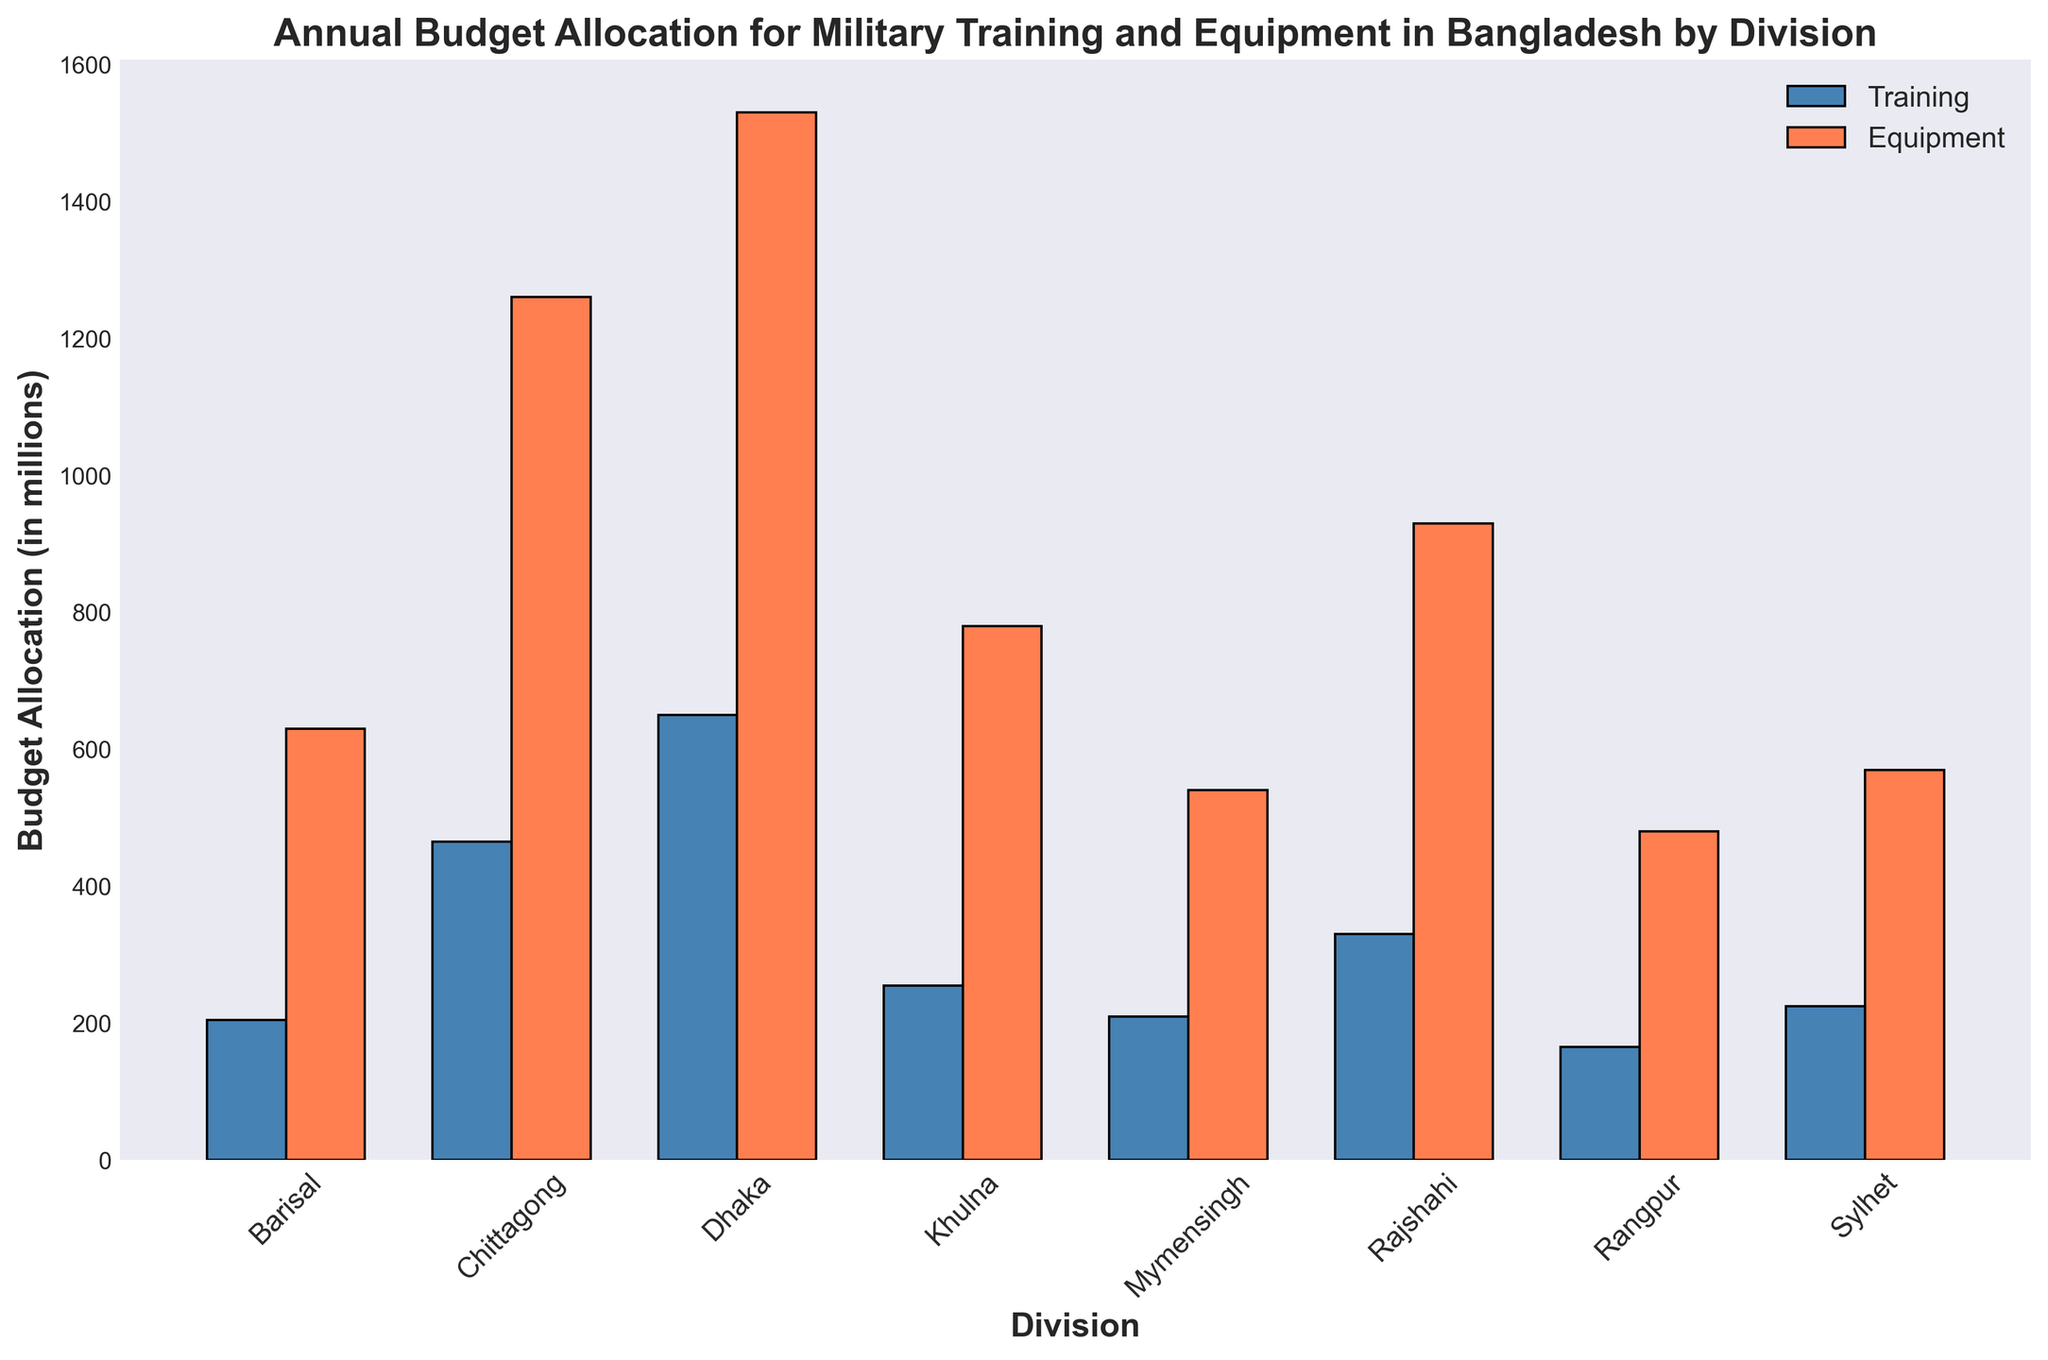Which division has the highest budget allocation for military training? The tallest blue bar represents the division with the highest allocation for military training. In the plot, Dhaka's blue bar is the highest.
Answer: Dhaka Which division has the lowest budget allocation for equipment? The shortest coral (red) bar represents the division with the lowest allocation for equipment. In the plot, Rangpur's coral bar is the shortest.
Answer: Rangpur What is the total budget allocation (Training + Equipment) for the Sylhet division? Add the height of Sylhet's blue bar (Training) and coral bar (Equipment). The Training budget is 225, and the Equipment budget is 570. Therefore, the total allocation is 225 + 570.
Answer: 395 Compare the budget allocation between Dhaka and Chittagong for equipment, and identify which division has a higher allocation. Compare the height of Dhaka's coral bar with Chittagong's coral bar. Dhaka's bar is higher in comparison to Chittagong's.
Answer: Dhaka What is the difference in budget allocation for training between Khulna and Barisal? Subtract the height of Barisal's blue bar (90) from Khulna's blue bar (255). Therefore, the difference is 255 - 90.
Answer: 165 Which division has a higher combined budget allocation for military training and equipment - Rajshahi or Mymensingh? Calculate the sum of the Training and Equipment budgets for both Rajshahi (330 + 930 = 1260) and Mymensingh (210 + 540 = 750) by adding the heights of their respective bars. Rajshahi has a higher combined allocation.
Answer: Rajshahi What is the average budget allocation for military training across all divisions? Sum the heights of all the blue bars (230 + 160 + 120 + 90 + 75 + 80 + 60 + 75 = 890) and divide by the number of divisions (8). So, the average is 890 / 8.
Answer: 111.25 Which division's budget allocation for training is closest to the median value among all divisions? List the budget values for training (Dhaka: 230, Chittagong: 160, Rajshahi: 120, Khulna: 90, Barisal: 75, Sylhet: 80, Rangpur: 60, Mymensingh: 75), arrange them (60, 75, 75, 80, 90, 120, 160, 230), find the median (average of the 4th and 5th values: (80 + 90) / 2 = 85), and identify which division has a value closest to 85.
Answer: Sylhet Which division shows a proportional similarity in budget allocation for training and equipment? Identify divisions where the blue and coral bars have similar heights. Khulna shows closer proportions, as the heights of both bars are closer compared to other divisions.
Answer: Khulna 